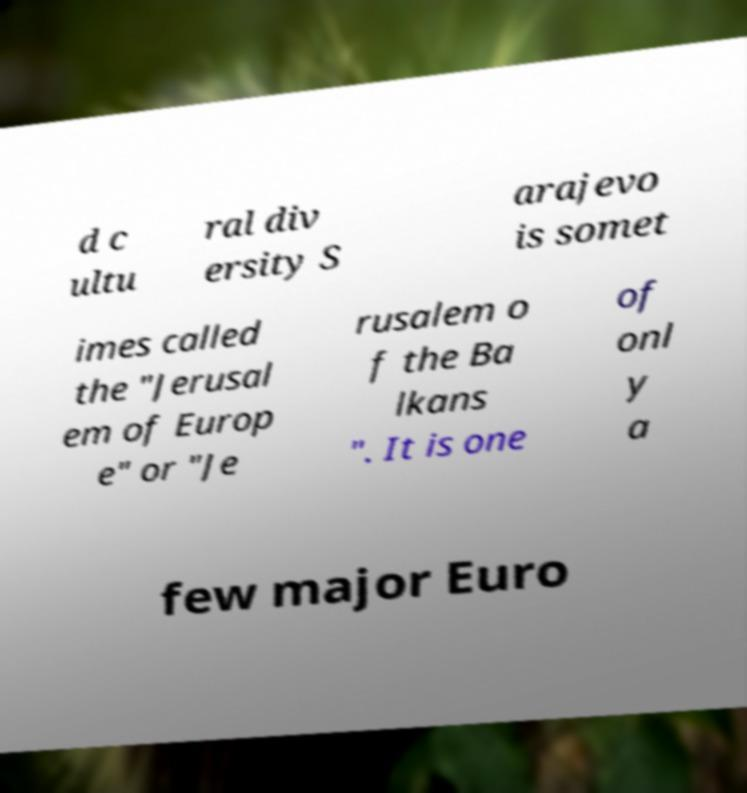There's text embedded in this image that I need extracted. Can you transcribe it verbatim? d c ultu ral div ersity S arajevo is somet imes called the "Jerusal em of Europ e" or "Je rusalem o f the Ba lkans ". It is one of onl y a few major Euro 